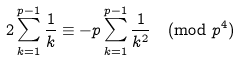Convert formula to latex. <formula><loc_0><loc_0><loc_500><loc_500>2 \sum _ { k = 1 } ^ { p - 1 } \frac { 1 } { k } \equiv - p \sum _ { k = 1 } ^ { p - 1 } \frac { 1 } { k ^ { 2 } } \pmod { p ^ { 4 } }</formula> 